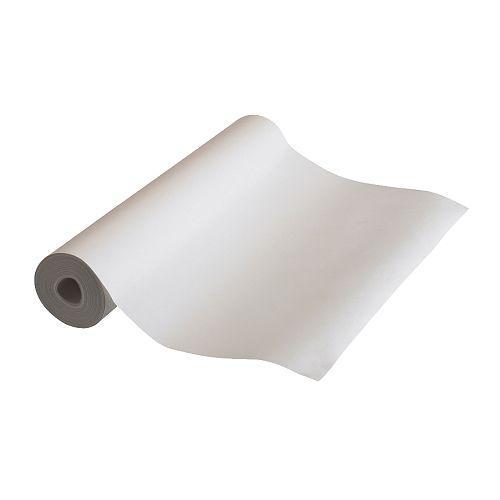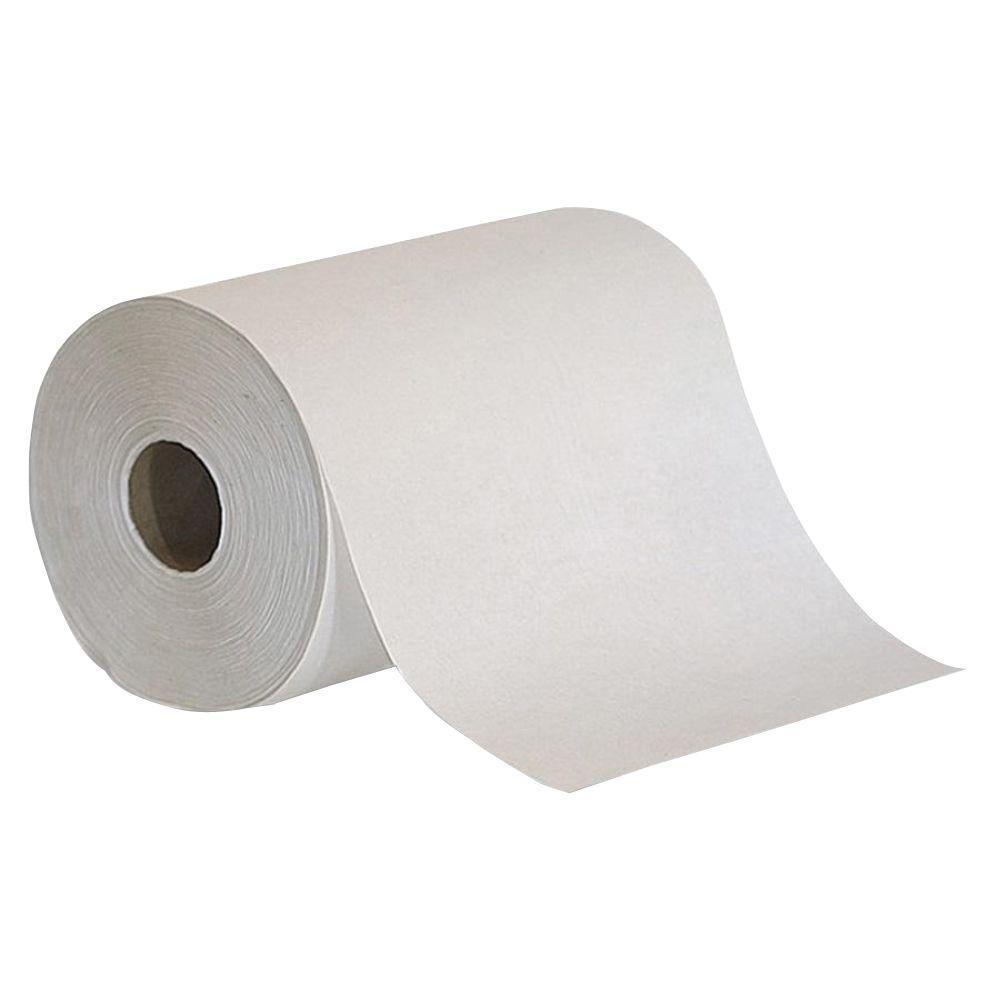The first image is the image on the left, the second image is the image on the right. Given the left and right images, does the statement "The right-hand roll is noticeably browner and darker in color." hold true? Answer yes or no. No. 